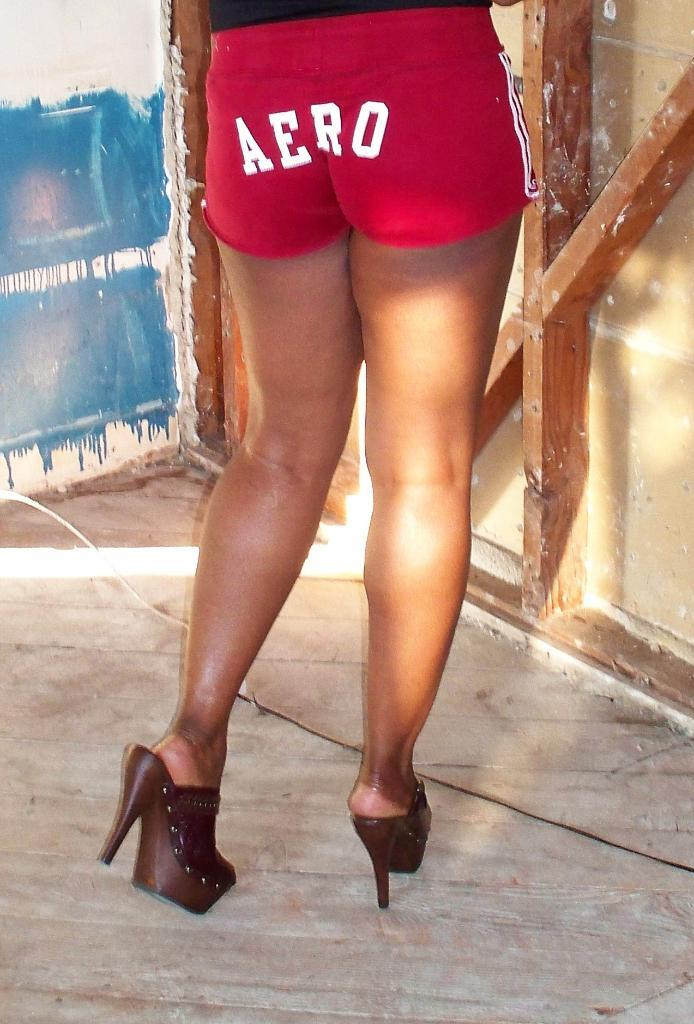<image>
Share a concise interpretation of the image provided. A woman wears red shorts that have AERO in white letters. 